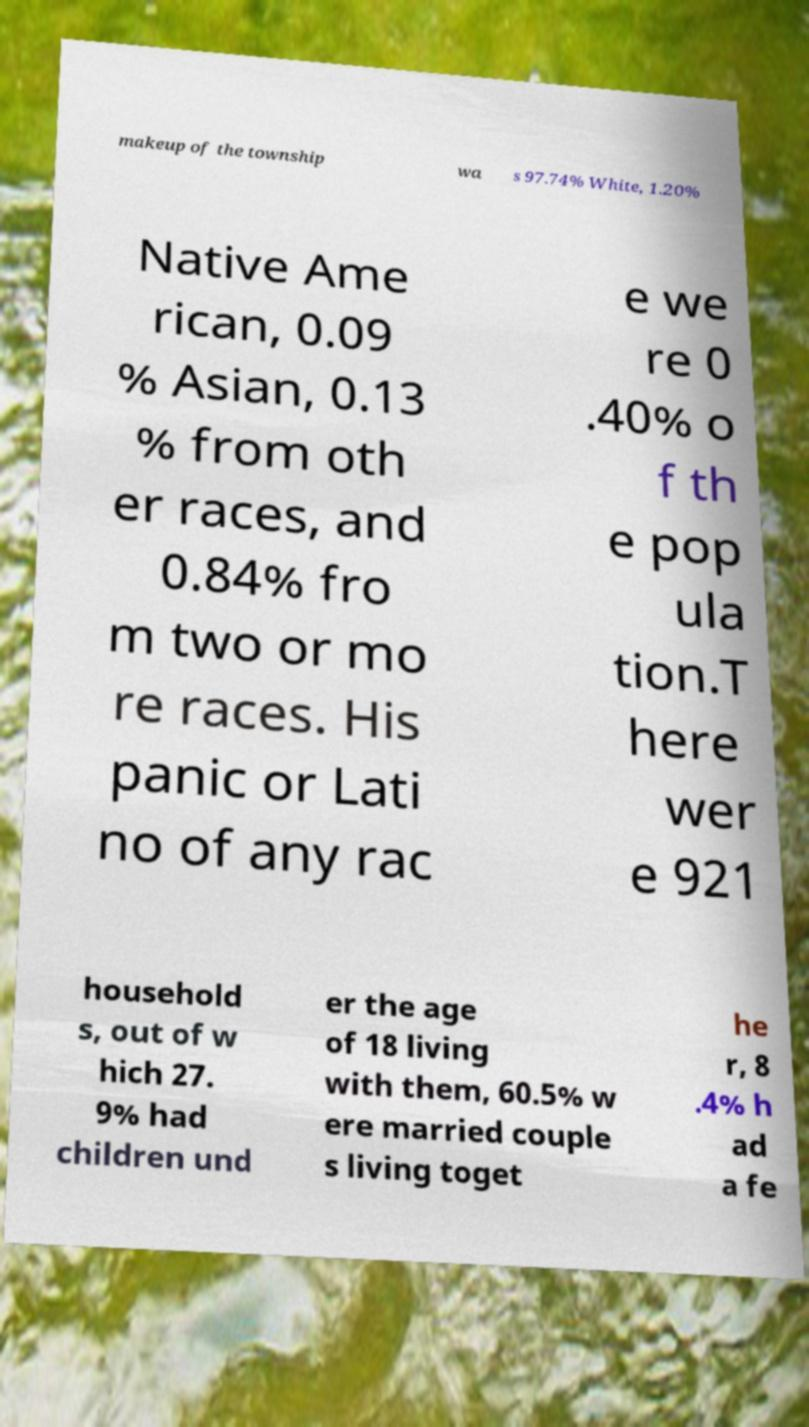What messages or text are displayed in this image? I need them in a readable, typed format. makeup of the township wa s 97.74% White, 1.20% Native Ame rican, 0.09 % Asian, 0.13 % from oth er races, and 0.84% fro m two or mo re races. His panic or Lati no of any rac e we re 0 .40% o f th e pop ula tion.T here wer e 921 household s, out of w hich 27. 9% had children und er the age of 18 living with them, 60.5% w ere married couple s living toget he r, 8 .4% h ad a fe 